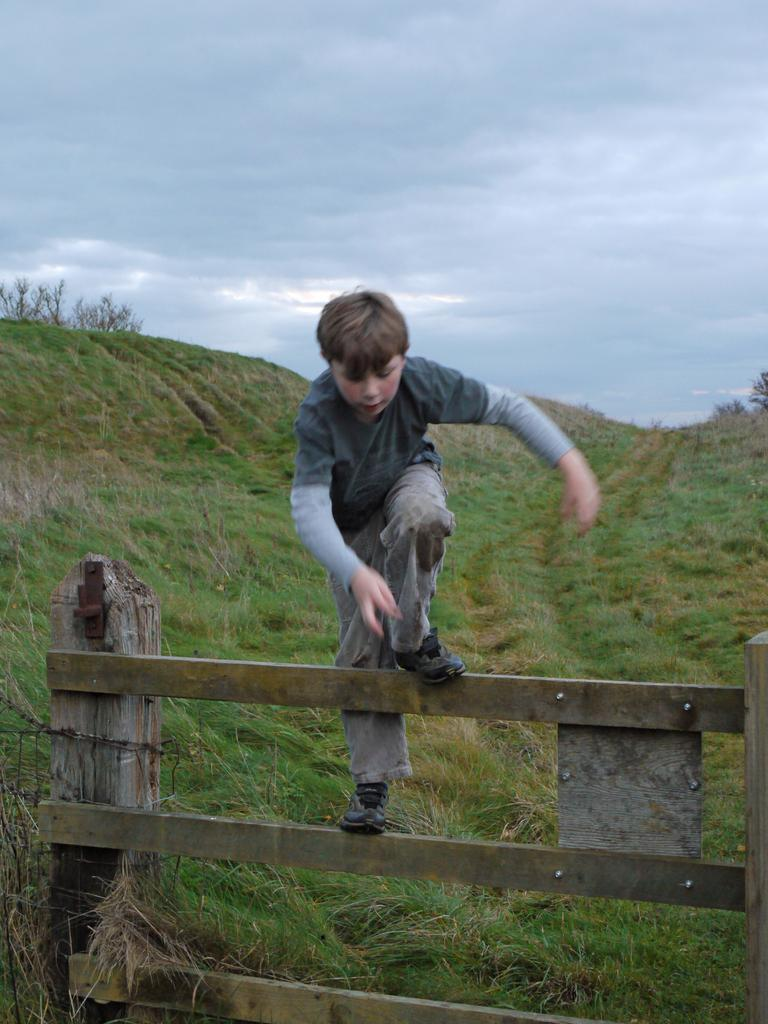What is the boy doing in the image? The boy is standing on a wooden railing in the image. What can be seen in the background of the image? There are trees visible in the background. What is visible at the top of the image? The sky is visible at the top of the image. What can be observed in the sky? Clouds are present in the sky. What is visible at the bottom of the image? Grass is visible at the bottom of the image. What type of dinner is the boy preparing on the railing? There is no dinner or preparation of food visible in the image; the boy is simply standing on the wooden railing. 